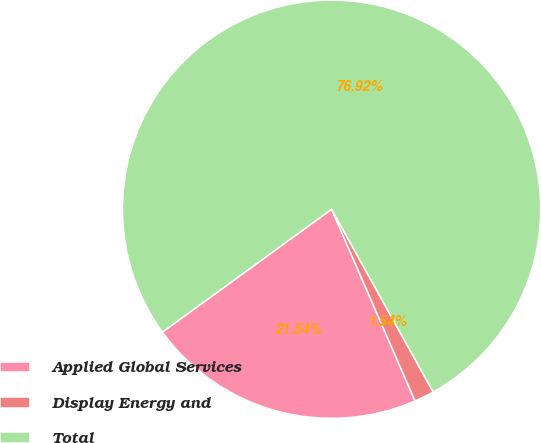Convert chart. <chart><loc_0><loc_0><loc_500><loc_500><pie_chart><fcel>Applied Global Services<fcel>Display Energy and<fcel>Total<nl><fcel>21.54%<fcel>1.54%<fcel>76.92%<nl></chart> 